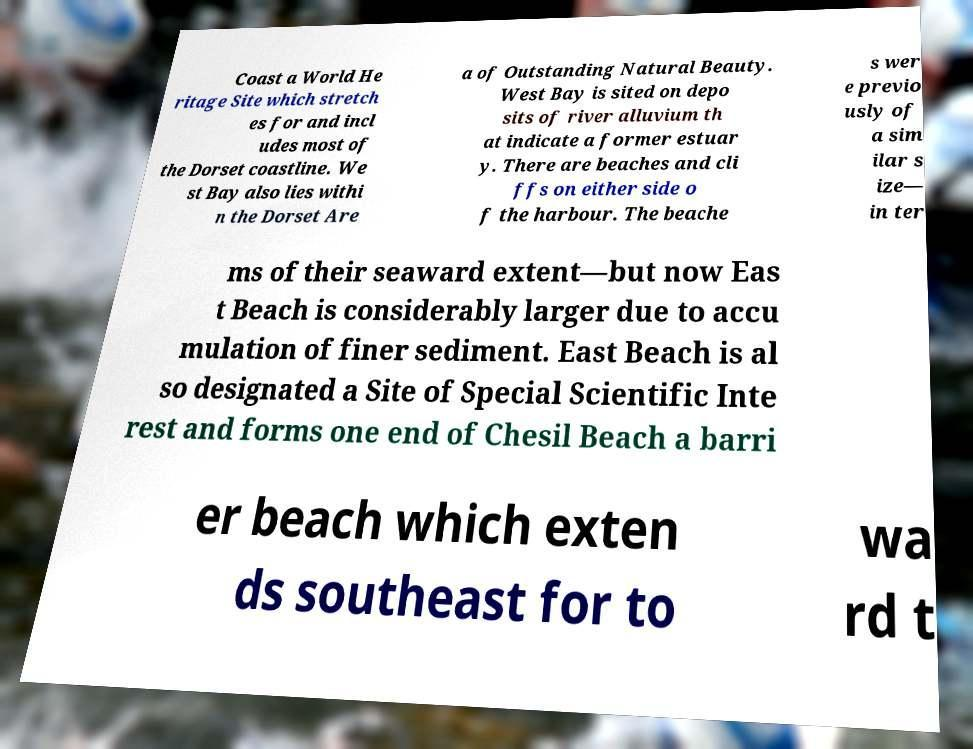Could you assist in decoding the text presented in this image and type it out clearly? Coast a World He ritage Site which stretch es for and incl udes most of the Dorset coastline. We st Bay also lies withi n the Dorset Are a of Outstanding Natural Beauty. West Bay is sited on depo sits of river alluvium th at indicate a former estuar y. There are beaches and cli ffs on either side o f the harbour. The beache s wer e previo usly of a sim ilar s ize— in ter ms of their seaward extent—but now Eas t Beach is considerably larger due to accu mulation of finer sediment. East Beach is al so designated a Site of Special Scientific Inte rest and forms one end of Chesil Beach a barri er beach which exten ds southeast for to wa rd t 